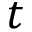<formula> <loc_0><loc_0><loc_500><loc_500>t</formula> 